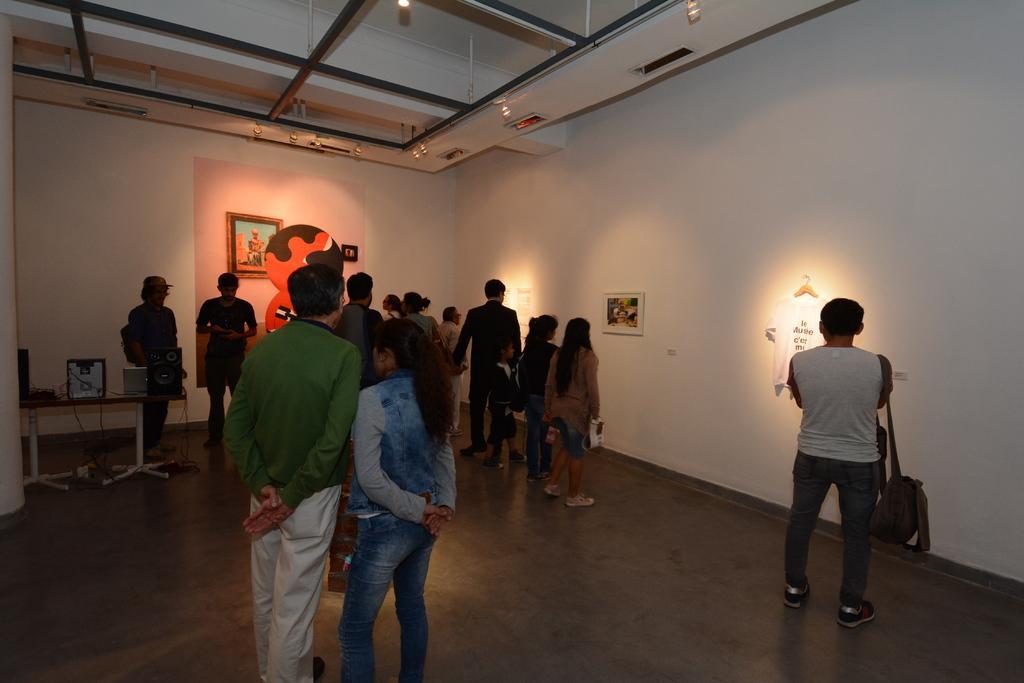In one or two sentences, can you explain what this image depicts? In the foreground of this image, there are persons standing on the floor. In the background, to the wall, there is a cloth hanging, few frames to the wall. On the left, there is a table on which speaker box, monitor and CPU is placed on it. On the top, there are lights to the ceiling. 